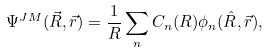<formula> <loc_0><loc_0><loc_500><loc_500>\Psi ^ { J M } ( \vec { R } , \vec { r } ) = \frac { 1 } { R } \sum _ { n } C _ { n } ( R ) \phi _ { n } ( \hat { R } , \vec { r } ) ,</formula> 